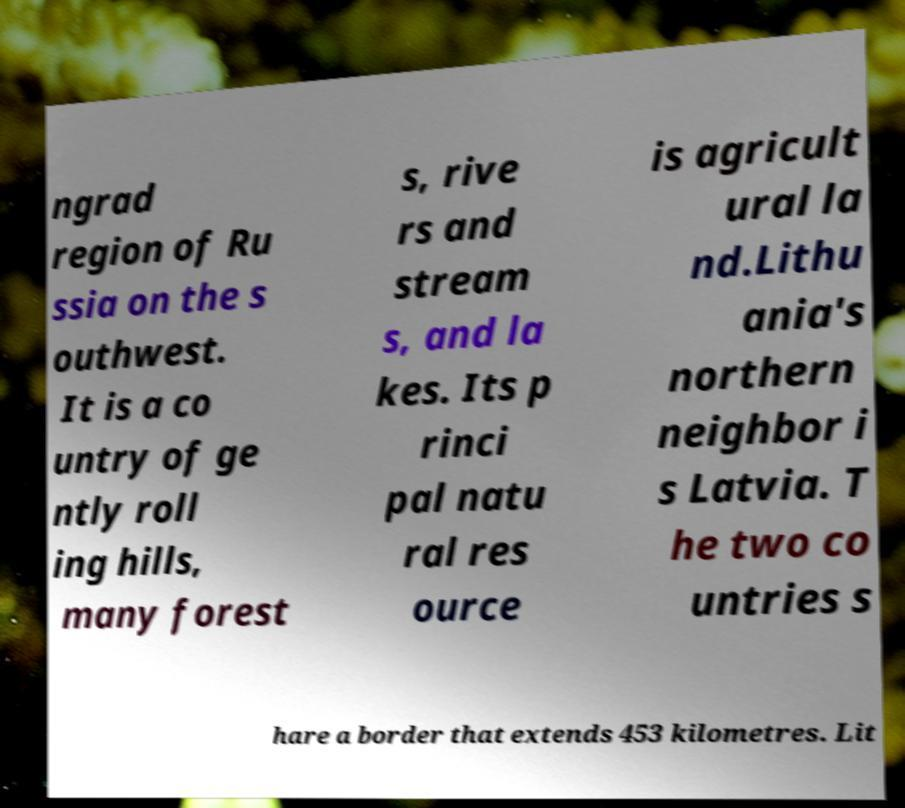There's text embedded in this image that I need extracted. Can you transcribe it verbatim? ngrad region of Ru ssia on the s outhwest. It is a co untry of ge ntly roll ing hills, many forest s, rive rs and stream s, and la kes. Its p rinci pal natu ral res ource is agricult ural la nd.Lithu ania's northern neighbor i s Latvia. T he two co untries s hare a border that extends 453 kilometres. Lit 